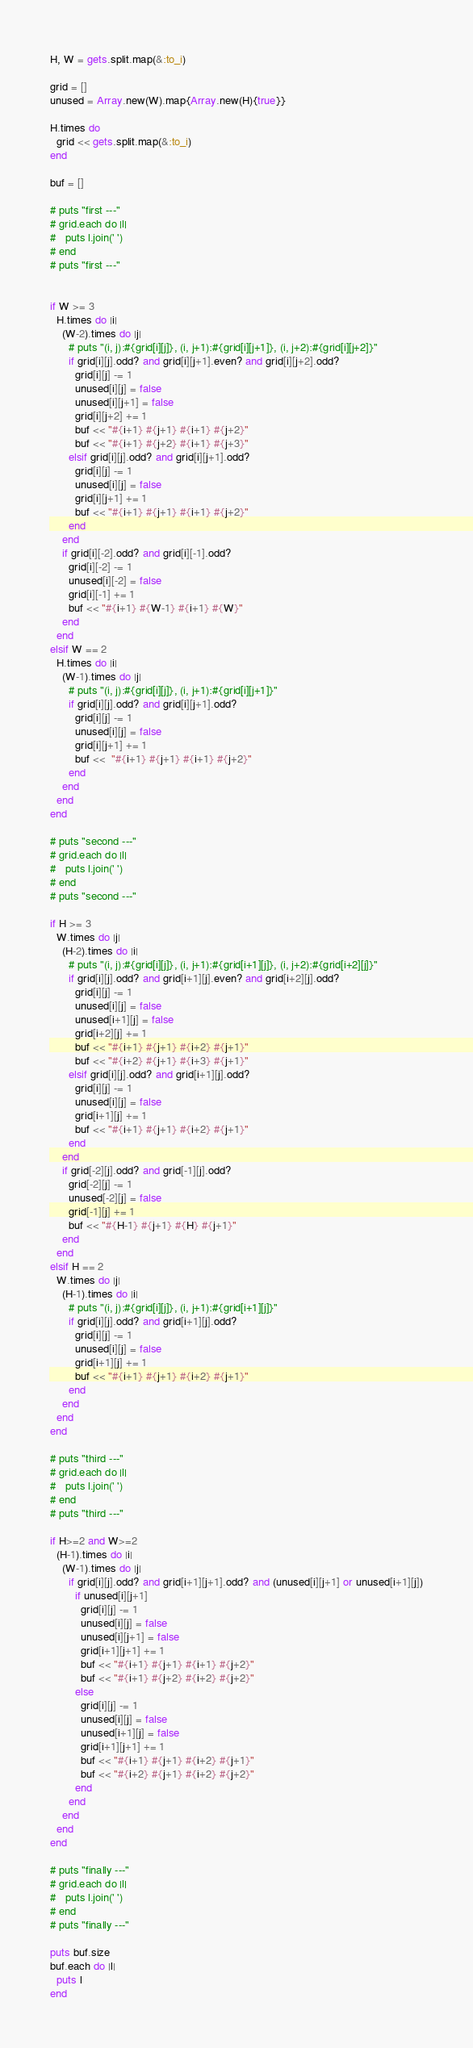<code> <loc_0><loc_0><loc_500><loc_500><_Ruby_>H, W = gets.split.map(&:to_i)

grid = []
unused = Array.new(W).map{Array.new(H){true}}

H.times do
  grid << gets.split.map(&:to_i)
end

buf = []

# puts "first ---"
# grid.each do |l|
#   puts l.join(' ')
# end
# puts "first ---"


if W >= 3
  H.times do |i|
    (W-2).times do |j|
      # puts "(i, j):#{grid[i][j]}, (i, j+1):#{grid[i][j+1]}, (i, j+2):#{grid[i][j+2]}"
      if grid[i][j].odd? and grid[i][j+1].even? and grid[i][j+2].odd?
        grid[i][j] -= 1
        unused[i][j] = false
        unused[i][j+1] = false
        grid[i][j+2] += 1
        buf << "#{i+1} #{j+1} #{i+1} #{j+2}"
        buf << "#{i+1} #{j+2} #{i+1} #{j+3}"
      elsif grid[i][j].odd? and grid[i][j+1].odd?
        grid[i][j] -= 1
        unused[i][j] = false
        grid[i][j+1] += 1
        buf << "#{i+1} #{j+1} #{i+1} #{j+2}"
      end 
    end
    if grid[i][-2].odd? and grid[i][-1].odd?
      grid[i][-2] -= 1
      unused[i][-2] = false
      grid[i][-1] += 1
      buf << "#{i+1} #{W-1} #{i+1} #{W}"
    end
  end
elsif W == 2
  H.times do |i|
    (W-1).times do |j|
      # puts "(i, j):#{grid[i][j]}, (i, j+1):#{grid[i][j+1]}"
      if grid[i][j].odd? and grid[i][j+1].odd?
        grid[i][j] -= 1
        unused[i][j] = false
        grid[i][j+1] += 1
        buf <<  "#{i+1} #{j+1} #{i+1} #{j+2}"
      end
    end
  end
end

# puts "second ---"
# grid.each do |l|
#   puts l.join(' ')
# end
# puts "second ---"

if H >= 3
  W.times do |j|
    (H-2).times do |i|
      # puts "(i, j):#{grid[i][j]}, (i, j+1):#{grid[i+1][j]}, (i, j+2):#{grid[i+2][j]}"
      if grid[i][j].odd? and grid[i+1][j].even? and grid[i+2][j].odd?
        grid[i][j] -= 1
        unused[i][j] = false
        unused[i+1][j] = false
        grid[i+2][j] += 1
        buf << "#{i+1} #{j+1} #{i+2} #{j+1}"
        buf << "#{i+2} #{j+1} #{i+3} #{j+1}"
      elsif grid[i][j].odd? and grid[i+1][j].odd?
        grid[i][j] -= 1
        unused[i][j] = false
        grid[i+1][j] += 1
        buf << "#{i+1} #{j+1} #{i+2} #{j+1}"
      end 
    end
    if grid[-2][j].odd? and grid[-1][j].odd?
      grid[-2][j] -= 1
      unused[-2][j] = false
      grid[-1][j] += 1
      buf << "#{H-1} #{j+1} #{H} #{j+1}"
    end
  end
elsif H == 2
  W.times do |j|
    (H-1).times do |i|
      # puts "(i, j):#{grid[i][j]}, (i, j+1):#{grid[i+1][j]}"
      if grid[i][j].odd? and grid[i+1][j].odd?
        grid[i][j] -= 1
        unused[i][j] = false
        grid[i+1][j] += 1
        buf << "#{i+1} #{j+1} #{i+2} #{j+1}"
      end
    end
  end
end

# puts "third ---"
# grid.each do |l|
#   puts l.join(' ')
# end
# puts "third ---"

if H>=2 and W>=2
  (H-1).times do |i|
    (W-1).times do |j|
      if grid[i][j].odd? and grid[i+1][j+1].odd? and (unused[i][j+1] or unused[i+1][j])
        if unused[i][j+1]
          grid[i][j] -= 1
          unused[i][j] = false
          unused[i][j+1] = false
          grid[i+1][j+1] += 1
          buf << "#{i+1} #{j+1} #{i+1} #{j+2}"
          buf << "#{i+1} #{j+2} #{i+2} #{j+2}"
        else
          grid[i][j] -= 1
          unused[i][j] = false
          unused[i+1][j] = false
          grid[i+1][j+1] += 1
          buf << "#{i+1} #{j+1} #{i+2} #{j+1}"
          buf << "#{i+2} #{j+1} #{i+2} #{j+2}"
        end
      end
    end
  end
end

# puts "finally ---"
# grid.each do |l|
#   puts l.join(' ')
# end
# puts "finally ---"

puts buf.size
buf.each do |l|
  puts l
end</code> 